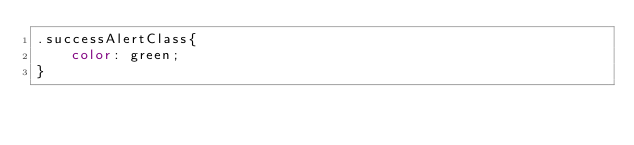<code> <loc_0><loc_0><loc_500><loc_500><_CSS_>.successAlertClass{
    color: green;
}</code> 